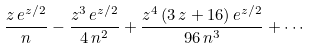Convert formula to latex. <formula><loc_0><loc_0><loc_500><loc_500>\frac { z \, e ^ { z / 2 } } { n } - \frac { z ^ { 3 } \, e ^ { z / 2 } } { 4 \, n ^ { 2 } } + \frac { z ^ { 4 } \, ( 3 \, z + 1 6 ) \, e ^ { z / 2 } } { 9 6 \, n ^ { 3 } } + \cdots</formula> 